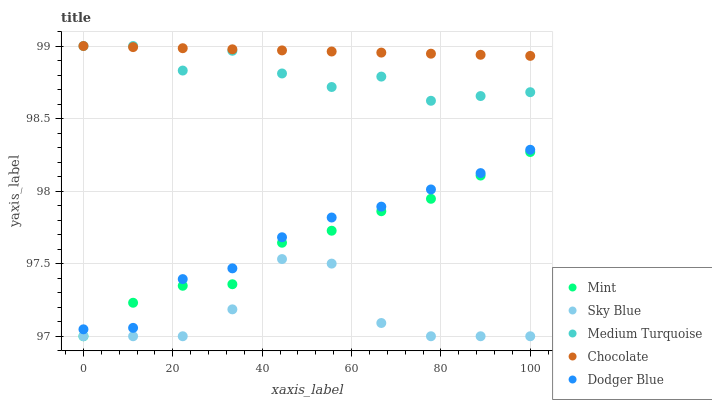Does Sky Blue have the minimum area under the curve?
Answer yes or no. Yes. Does Chocolate have the maximum area under the curve?
Answer yes or no. Yes. Does Mint have the minimum area under the curve?
Answer yes or no. No. Does Mint have the maximum area under the curve?
Answer yes or no. No. Is Chocolate the smoothest?
Answer yes or no. Yes. Is Sky Blue the roughest?
Answer yes or no. Yes. Is Mint the smoothest?
Answer yes or no. No. Is Mint the roughest?
Answer yes or no. No. Does Sky Blue have the lowest value?
Answer yes or no. Yes. Does Dodger Blue have the lowest value?
Answer yes or no. No. Does Chocolate have the highest value?
Answer yes or no. Yes. Does Mint have the highest value?
Answer yes or no. No. Is Sky Blue less than Medium Turquoise?
Answer yes or no. Yes. Is Chocolate greater than Mint?
Answer yes or no. Yes. Does Dodger Blue intersect Mint?
Answer yes or no. Yes. Is Dodger Blue less than Mint?
Answer yes or no. No. Is Dodger Blue greater than Mint?
Answer yes or no. No. Does Sky Blue intersect Medium Turquoise?
Answer yes or no. No. 